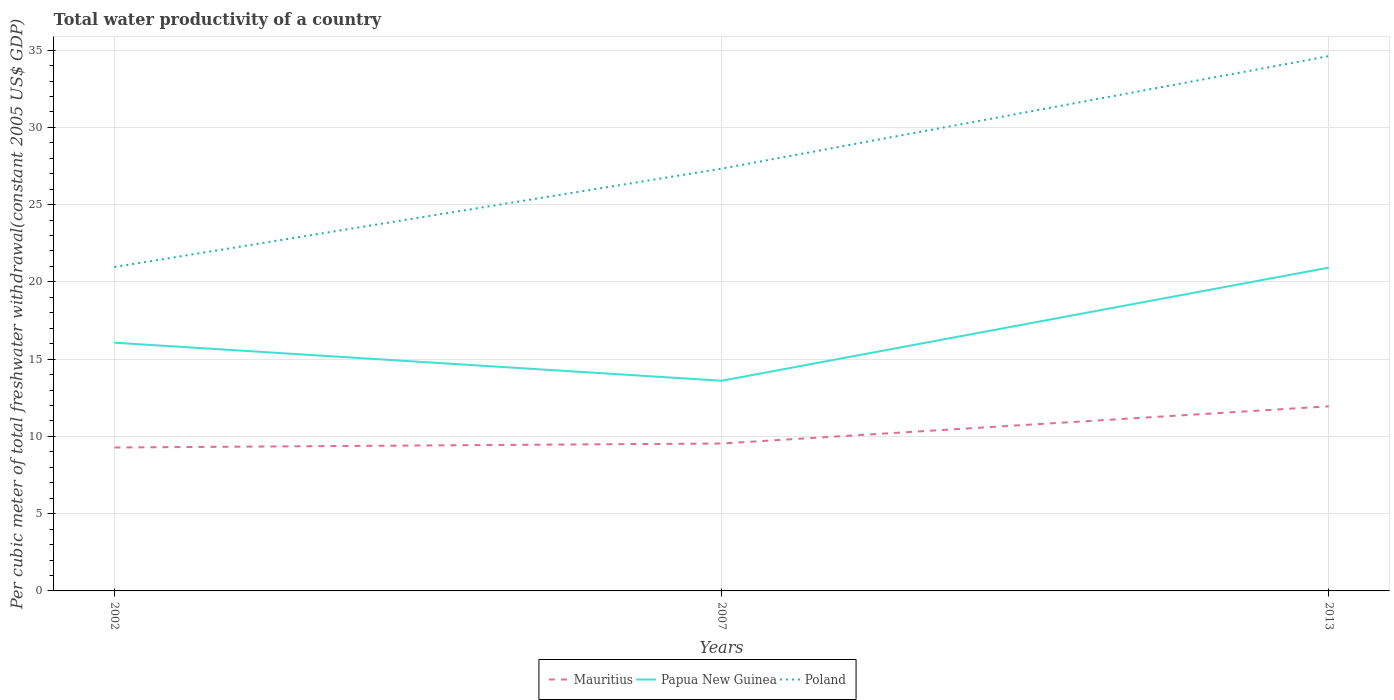How many different coloured lines are there?
Ensure brevity in your answer.  3. Is the number of lines equal to the number of legend labels?
Offer a very short reply. Yes. Across all years, what is the maximum total water productivity in Poland?
Make the answer very short. 20.96. What is the total total water productivity in Papua New Guinea in the graph?
Provide a short and direct response. -4.86. What is the difference between the highest and the second highest total water productivity in Papua New Guinea?
Offer a terse response. 7.32. What is the difference between the highest and the lowest total water productivity in Poland?
Provide a succinct answer. 1. Are the values on the major ticks of Y-axis written in scientific E-notation?
Your response must be concise. No. Does the graph contain any zero values?
Give a very brief answer. No. Does the graph contain grids?
Provide a succinct answer. Yes. Where does the legend appear in the graph?
Make the answer very short. Bottom center. What is the title of the graph?
Offer a terse response. Total water productivity of a country. What is the label or title of the Y-axis?
Your answer should be compact. Per cubic meter of total freshwater withdrawal(constant 2005 US$ GDP). What is the Per cubic meter of total freshwater withdrawal(constant 2005 US$ GDP) in Mauritius in 2002?
Provide a short and direct response. 9.28. What is the Per cubic meter of total freshwater withdrawal(constant 2005 US$ GDP) in Papua New Guinea in 2002?
Provide a short and direct response. 16.07. What is the Per cubic meter of total freshwater withdrawal(constant 2005 US$ GDP) in Poland in 2002?
Make the answer very short. 20.96. What is the Per cubic meter of total freshwater withdrawal(constant 2005 US$ GDP) in Mauritius in 2007?
Your response must be concise. 9.54. What is the Per cubic meter of total freshwater withdrawal(constant 2005 US$ GDP) of Papua New Guinea in 2007?
Keep it short and to the point. 13.6. What is the Per cubic meter of total freshwater withdrawal(constant 2005 US$ GDP) of Poland in 2007?
Provide a succinct answer. 27.33. What is the Per cubic meter of total freshwater withdrawal(constant 2005 US$ GDP) in Mauritius in 2013?
Provide a short and direct response. 11.95. What is the Per cubic meter of total freshwater withdrawal(constant 2005 US$ GDP) in Papua New Guinea in 2013?
Provide a short and direct response. 20.92. What is the Per cubic meter of total freshwater withdrawal(constant 2005 US$ GDP) of Poland in 2013?
Offer a terse response. 34.61. Across all years, what is the maximum Per cubic meter of total freshwater withdrawal(constant 2005 US$ GDP) in Mauritius?
Your answer should be very brief. 11.95. Across all years, what is the maximum Per cubic meter of total freshwater withdrawal(constant 2005 US$ GDP) in Papua New Guinea?
Your answer should be very brief. 20.92. Across all years, what is the maximum Per cubic meter of total freshwater withdrawal(constant 2005 US$ GDP) in Poland?
Your answer should be compact. 34.61. Across all years, what is the minimum Per cubic meter of total freshwater withdrawal(constant 2005 US$ GDP) of Mauritius?
Give a very brief answer. 9.28. Across all years, what is the minimum Per cubic meter of total freshwater withdrawal(constant 2005 US$ GDP) of Papua New Guinea?
Your answer should be compact. 13.6. Across all years, what is the minimum Per cubic meter of total freshwater withdrawal(constant 2005 US$ GDP) of Poland?
Offer a terse response. 20.96. What is the total Per cubic meter of total freshwater withdrawal(constant 2005 US$ GDP) in Mauritius in the graph?
Offer a very short reply. 30.77. What is the total Per cubic meter of total freshwater withdrawal(constant 2005 US$ GDP) of Papua New Guinea in the graph?
Ensure brevity in your answer.  50.59. What is the total Per cubic meter of total freshwater withdrawal(constant 2005 US$ GDP) in Poland in the graph?
Provide a short and direct response. 82.9. What is the difference between the Per cubic meter of total freshwater withdrawal(constant 2005 US$ GDP) in Mauritius in 2002 and that in 2007?
Offer a very short reply. -0.26. What is the difference between the Per cubic meter of total freshwater withdrawal(constant 2005 US$ GDP) of Papua New Guinea in 2002 and that in 2007?
Offer a terse response. 2.46. What is the difference between the Per cubic meter of total freshwater withdrawal(constant 2005 US$ GDP) of Poland in 2002 and that in 2007?
Provide a short and direct response. -6.37. What is the difference between the Per cubic meter of total freshwater withdrawal(constant 2005 US$ GDP) of Mauritius in 2002 and that in 2013?
Your answer should be very brief. -2.66. What is the difference between the Per cubic meter of total freshwater withdrawal(constant 2005 US$ GDP) of Papua New Guinea in 2002 and that in 2013?
Offer a very short reply. -4.86. What is the difference between the Per cubic meter of total freshwater withdrawal(constant 2005 US$ GDP) of Poland in 2002 and that in 2013?
Your response must be concise. -13.65. What is the difference between the Per cubic meter of total freshwater withdrawal(constant 2005 US$ GDP) in Mauritius in 2007 and that in 2013?
Your response must be concise. -2.41. What is the difference between the Per cubic meter of total freshwater withdrawal(constant 2005 US$ GDP) of Papua New Guinea in 2007 and that in 2013?
Your answer should be compact. -7.32. What is the difference between the Per cubic meter of total freshwater withdrawal(constant 2005 US$ GDP) in Poland in 2007 and that in 2013?
Provide a succinct answer. -7.28. What is the difference between the Per cubic meter of total freshwater withdrawal(constant 2005 US$ GDP) of Mauritius in 2002 and the Per cubic meter of total freshwater withdrawal(constant 2005 US$ GDP) of Papua New Guinea in 2007?
Your response must be concise. -4.32. What is the difference between the Per cubic meter of total freshwater withdrawal(constant 2005 US$ GDP) in Mauritius in 2002 and the Per cubic meter of total freshwater withdrawal(constant 2005 US$ GDP) in Poland in 2007?
Make the answer very short. -18.05. What is the difference between the Per cubic meter of total freshwater withdrawal(constant 2005 US$ GDP) in Papua New Guinea in 2002 and the Per cubic meter of total freshwater withdrawal(constant 2005 US$ GDP) in Poland in 2007?
Give a very brief answer. -11.26. What is the difference between the Per cubic meter of total freshwater withdrawal(constant 2005 US$ GDP) of Mauritius in 2002 and the Per cubic meter of total freshwater withdrawal(constant 2005 US$ GDP) of Papua New Guinea in 2013?
Your answer should be very brief. -11.64. What is the difference between the Per cubic meter of total freshwater withdrawal(constant 2005 US$ GDP) in Mauritius in 2002 and the Per cubic meter of total freshwater withdrawal(constant 2005 US$ GDP) in Poland in 2013?
Make the answer very short. -25.33. What is the difference between the Per cubic meter of total freshwater withdrawal(constant 2005 US$ GDP) in Papua New Guinea in 2002 and the Per cubic meter of total freshwater withdrawal(constant 2005 US$ GDP) in Poland in 2013?
Give a very brief answer. -18.55. What is the difference between the Per cubic meter of total freshwater withdrawal(constant 2005 US$ GDP) of Mauritius in 2007 and the Per cubic meter of total freshwater withdrawal(constant 2005 US$ GDP) of Papua New Guinea in 2013?
Offer a terse response. -11.38. What is the difference between the Per cubic meter of total freshwater withdrawal(constant 2005 US$ GDP) in Mauritius in 2007 and the Per cubic meter of total freshwater withdrawal(constant 2005 US$ GDP) in Poland in 2013?
Keep it short and to the point. -25.07. What is the difference between the Per cubic meter of total freshwater withdrawal(constant 2005 US$ GDP) in Papua New Guinea in 2007 and the Per cubic meter of total freshwater withdrawal(constant 2005 US$ GDP) in Poland in 2013?
Give a very brief answer. -21.01. What is the average Per cubic meter of total freshwater withdrawal(constant 2005 US$ GDP) in Mauritius per year?
Your response must be concise. 10.26. What is the average Per cubic meter of total freshwater withdrawal(constant 2005 US$ GDP) of Papua New Guinea per year?
Your answer should be very brief. 16.86. What is the average Per cubic meter of total freshwater withdrawal(constant 2005 US$ GDP) in Poland per year?
Ensure brevity in your answer.  27.63. In the year 2002, what is the difference between the Per cubic meter of total freshwater withdrawal(constant 2005 US$ GDP) of Mauritius and Per cubic meter of total freshwater withdrawal(constant 2005 US$ GDP) of Papua New Guinea?
Give a very brief answer. -6.78. In the year 2002, what is the difference between the Per cubic meter of total freshwater withdrawal(constant 2005 US$ GDP) of Mauritius and Per cubic meter of total freshwater withdrawal(constant 2005 US$ GDP) of Poland?
Your answer should be compact. -11.68. In the year 2002, what is the difference between the Per cubic meter of total freshwater withdrawal(constant 2005 US$ GDP) of Papua New Guinea and Per cubic meter of total freshwater withdrawal(constant 2005 US$ GDP) of Poland?
Give a very brief answer. -4.9. In the year 2007, what is the difference between the Per cubic meter of total freshwater withdrawal(constant 2005 US$ GDP) in Mauritius and Per cubic meter of total freshwater withdrawal(constant 2005 US$ GDP) in Papua New Guinea?
Your answer should be very brief. -4.06. In the year 2007, what is the difference between the Per cubic meter of total freshwater withdrawal(constant 2005 US$ GDP) in Mauritius and Per cubic meter of total freshwater withdrawal(constant 2005 US$ GDP) in Poland?
Your response must be concise. -17.79. In the year 2007, what is the difference between the Per cubic meter of total freshwater withdrawal(constant 2005 US$ GDP) of Papua New Guinea and Per cubic meter of total freshwater withdrawal(constant 2005 US$ GDP) of Poland?
Provide a succinct answer. -13.73. In the year 2013, what is the difference between the Per cubic meter of total freshwater withdrawal(constant 2005 US$ GDP) in Mauritius and Per cubic meter of total freshwater withdrawal(constant 2005 US$ GDP) in Papua New Guinea?
Offer a very short reply. -8.98. In the year 2013, what is the difference between the Per cubic meter of total freshwater withdrawal(constant 2005 US$ GDP) in Mauritius and Per cubic meter of total freshwater withdrawal(constant 2005 US$ GDP) in Poland?
Your answer should be very brief. -22.66. In the year 2013, what is the difference between the Per cubic meter of total freshwater withdrawal(constant 2005 US$ GDP) of Papua New Guinea and Per cubic meter of total freshwater withdrawal(constant 2005 US$ GDP) of Poland?
Your answer should be very brief. -13.69. What is the ratio of the Per cubic meter of total freshwater withdrawal(constant 2005 US$ GDP) of Papua New Guinea in 2002 to that in 2007?
Provide a short and direct response. 1.18. What is the ratio of the Per cubic meter of total freshwater withdrawal(constant 2005 US$ GDP) in Poland in 2002 to that in 2007?
Offer a very short reply. 0.77. What is the ratio of the Per cubic meter of total freshwater withdrawal(constant 2005 US$ GDP) of Mauritius in 2002 to that in 2013?
Provide a short and direct response. 0.78. What is the ratio of the Per cubic meter of total freshwater withdrawal(constant 2005 US$ GDP) of Papua New Guinea in 2002 to that in 2013?
Offer a very short reply. 0.77. What is the ratio of the Per cubic meter of total freshwater withdrawal(constant 2005 US$ GDP) of Poland in 2002 to that in 2013?
Give a very brief answer. 0.61. What is the ratio of the Per cubic meter of total freshwater withdrawal(constant 2005 US$ GDP) of Mauritius in 2007 to that in 2013?
Make the answer very short. 0.8. What is the ratio of the Per cubic meter of total freshwater withdrawal(constant 2005 US$ GDP) in Papua New Guinea in 2007 to that in 2013?
Provide a short and direct response. 0.65. What is the ratio of the Per cubic meter of total freshwater withdrawal(constant 2005 US$ GDP) in Poland in 2007 to that in 2013?
Make the answer very short. 0.79. What is the difference between the highest and the second highest Per cubic meter of total freshwater withdrawal(constant 2005 US$ GDP) of Mauritius?
Offer a terse response. 2.41. What is the difference between the highest and the second highest Per cubic meter of total freshwater withdrawal(constant 2005 US$ GDP) of Papua New Guinea?
Keep it short and to the point. 4.86. What is the difference between the highest and the second highest Per cubic meter of total freshwater withdrawal(constant 2005 US$ GDP) in Poland?
Your answer should be compact. 7.28. What is the difference between the highest and the lowest Per cubic meter of total freshwater withdrawal(constant 2005 US$ GDP) in Mauritius?
Your answer should be compact. 2.66. What is the difference between the highest and the lowest Per cubic meter of total freshwater withdrawal(constant 2005 US$ GDP) of Papua New Guinea?
Provide a short and direct response. 7.32. What is the difference between the highest and the lowest Per cubic meter of total freshwater withdrawal(constant 2005 US$ GDP) of Poland?
Provide a short and direct response. 13.65. 